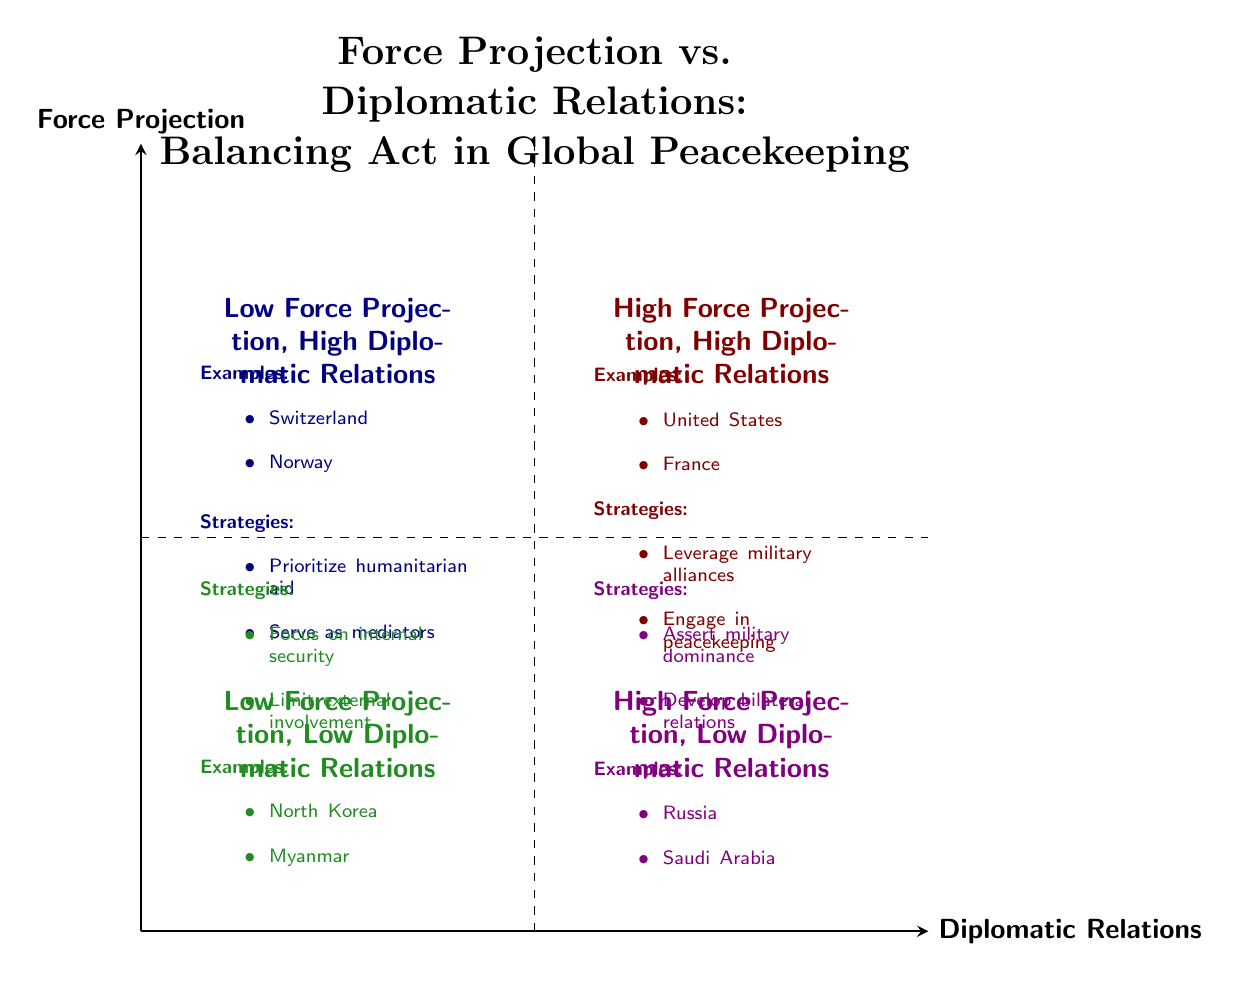What examples are found in the High Force Projection, High Diplomatic Relations quadrant? The question requires identifying the specific nodes in that quadrant. By examining the quadrant labeled "High Force Projection, High Diplomatic Relations" (Q2), we can see the examples listed: "United States" and "France."
Answer: United States, France What strategies are associated with Low Force Projection, High Diplomatic Relations? This question focuses on the "Low Force Projection, High Diplomatic Relations" quadrant (Q2) to find specific strategies listed there. The strategies include: "Prioritize humanitarian aid" and "Serve as mediators."
Answer: Prioritize humanitarian aid, Serve as mediators How many quadrants are labeled as having High Force Projection? This question looks for all quadrants with High Force Projection. There are two quadrants labeled: "High Force Projection, High Diplomatic Relations" (Q1) and "High Force Projection, Low Diplomatic Relations" (Q4), resulting in a total of two.
Answer: 2 Which quadrant contains North Korea as an example? The question is asking for a specific location based on the examples provided. North Korea is listed under the quadrant labeled "Low Force Projection, Low Diplomatic Relations" (Q3).
Answer: Low Force Projection, Low Diplomatic Relations What is the strategy employed by countries in the High Force Projection, Low Diplomatic Relations quadrant? To answer this, we need to refer to the "High Force Projection, Low Diplomatic Relations" quadrant (Q4). The listed strategies are: "Assert military dominance" and "Develop bilateral relations."
Answer: Assert military dominance, Develop bilateral relations What examples are associated with Low Force Projection, Low Diplomatic Relations? This question requires identifying examples found in that specific quadrant. Upon reviewing the "Low Force Projection, Low Diplomatic Relations" quadrant (Q3), the examples given are "North Korea" and "Myanmar."
Answer: North Korea, Myanmar Which quadrant emphasizes the combination of strong military and diplomatic presence? Here, we need to identify the quadrant that specifically mentions both high military force and strong diplomatic relations. This is clearly described in the "High Force Projection, High Diplomatic Relations" quadrant (Q1).
Answer: High Force Projection, High Diplomatic Relations What do the dashed lines in the diagram represent? The dashed lines represent the boundaries between the quadrants. They divide the chart into sections based on the levels of Force Projection (Y-axis) and Diplomatic Relations (X-axis).
Answer: Boundaries between quadrants How do the strategies differ between Q1 and Q4? This question requires understanding and comparing strategies between two quadrants. In "High Force Projection, High Diplomatic Relations" (Q1), the strategies focus on leveraging military alliances and engaging in peacekeeping. In contrast, "High Force Projection, Low Diplomatic Relations" (Q4) strategies emphasize asserting military dominance and developing bilateral relations.
Answer: Different focus on alliances vs. dominance 